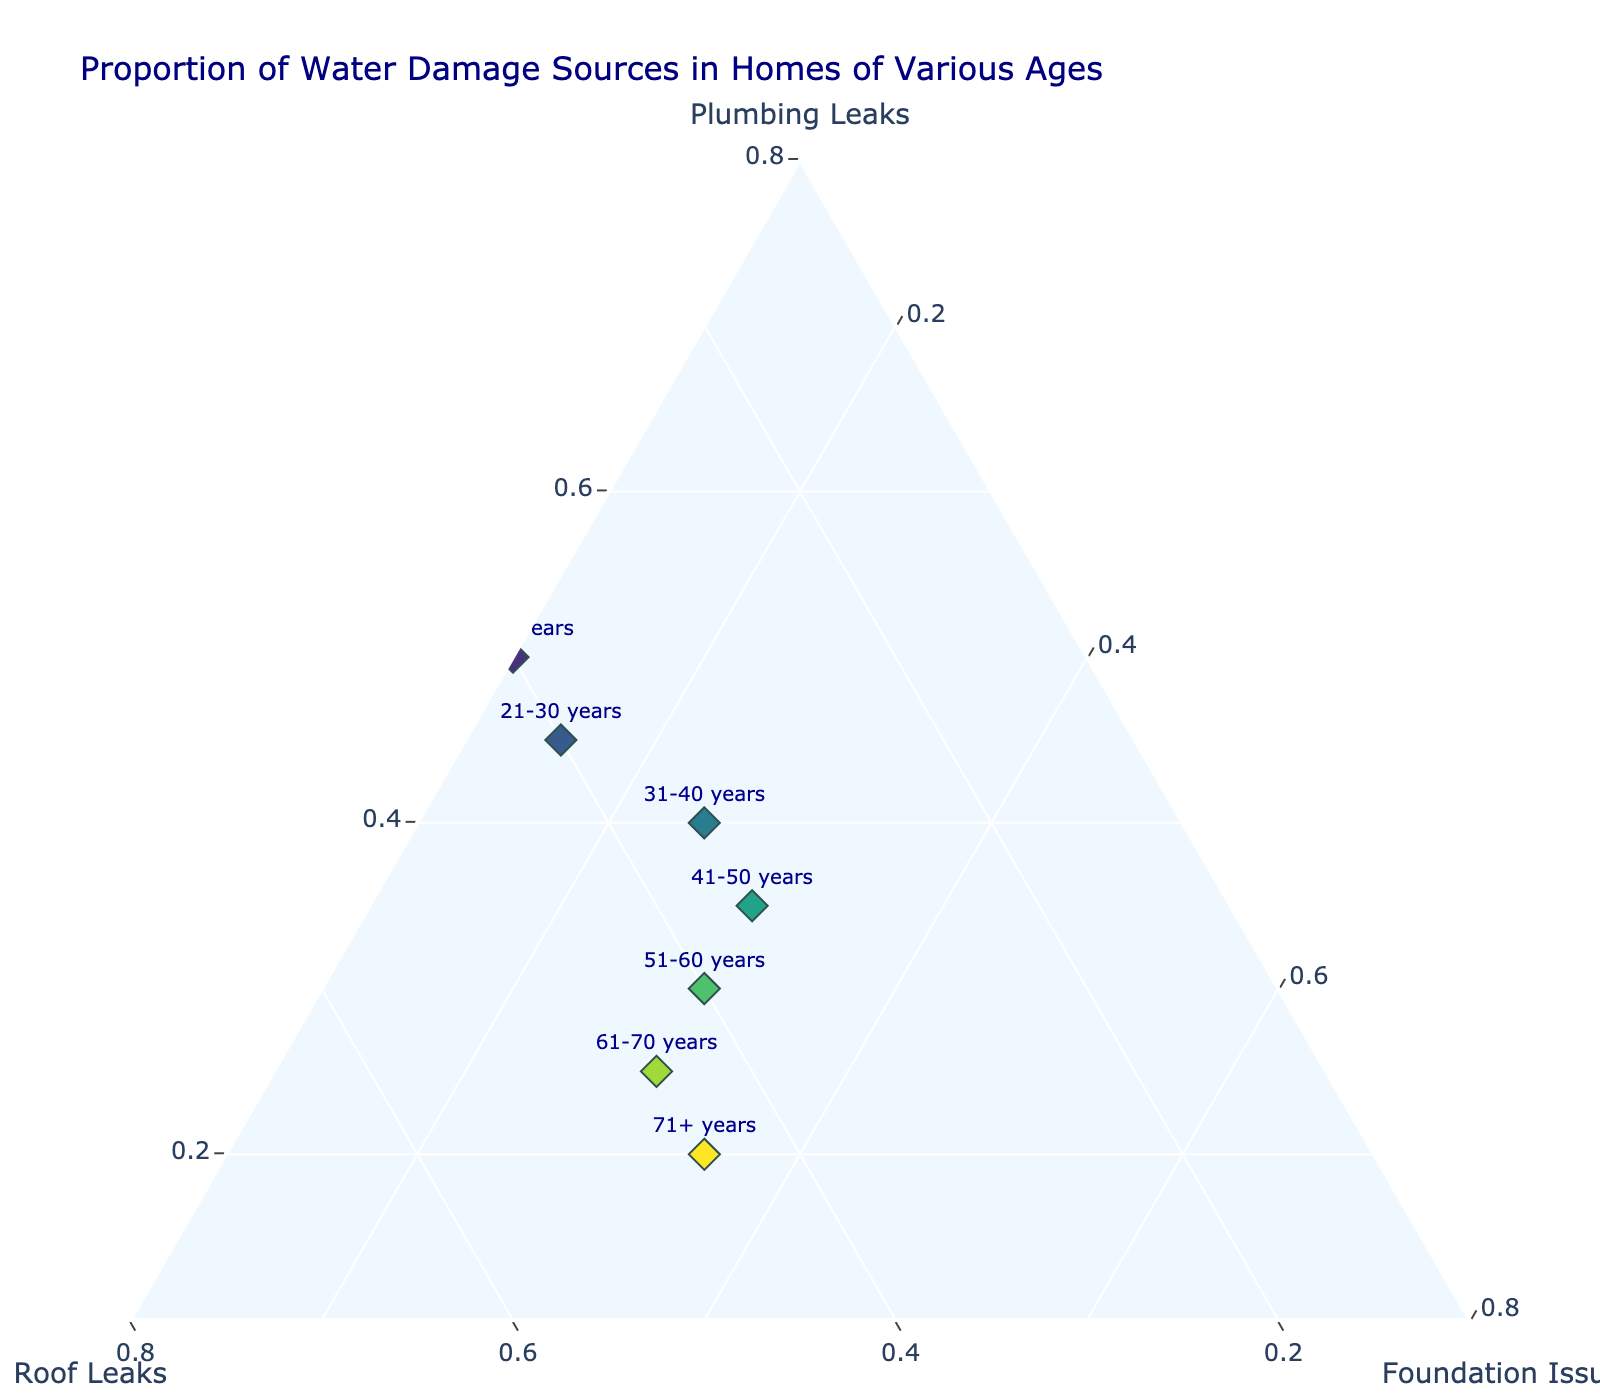what is the title of the figure? The title of the figure is usually stated at the top and it provides an overview of what the figure represents. In this case, it indicates that the plot is showing water damage sources in homes of different ages.
Answer: Proportion of Water Damage Sources in Homes of Various Ages How many data points are plotted in the figure? The number of data points equals the number of age ranges listed in the dataset. Each age range corresponds to a unique point on the ternary plot.
Answer: 8 Which source of water damage is highest in homes aged 61-70 years? By looking at the position of the marker for the 61-70 years age range on the ternary plot, it is closest to the vertex representing roof leaks. This indicates the highest proportion of water damage comes from roof leaks.
Answer: Roof leaks What is the proportion difference between plumbing leaks in homes aged 0-10 years and 71+ years? The proportion of plumbing leaks can be directly read from the ternary plot for each age range. For ages 0-10 years, it is 0.60 and for 71+ years, it is 0.20. The difference is 0.60 - 0.20 = 0.40.
Answer: 0.40 In which age range are foundation issues most prominent? For foundation issues to be most prominent, look for the age range marker closest to the foundation issues vertex. This is the 71+ years age range.
Answer: 71+ years How does the proportion of roof leaks change from homes aged 0-10 years to homes aged 51-60 years? In homes aged 0-10 years, roof leaks proportion is 0.35. In homes aged 51-60 years, roof leaks proportion is 0.40. It shows an increase in the proportion of roof leaks.
Answer: Increases What is the average proportion of foundation issues across all age ranges? The proportions of foundation issues for all age ranges can be summed up and then divided by the number of age ranges (8). (0.05 + 0.10 + 0.15 + 0.25 + 0.30 + 0.30 + 0.30 + 0.35) / 8 = 0.225
Answer: 0.225 Which age range has the lowest proportion of plumbing leaks? The age range with the marker closest to the foundation issues and roof leaks vertices indicates the lowest proportion of plumbing leaks. This is the 71+ years age range.
Answer: 71+ years Compare the proportions of roof leaks in homes aged 11-20 years and 31-40 years. Which one is higher? By examining the ternary plot, the proportion of roof leaks is the same for both age ranges 11-20 years and 31-40 years, each at 0.40 and 0.35 respectively.
Answer: Same Is there an age range where the proportions of roof leaks and foundation issues are equal? By referencing the ternary plot, the age range where the proportions of roof leaks and foundation issues are equal is 41-50 years, both at 0.35.
Answer: 41-50 years 